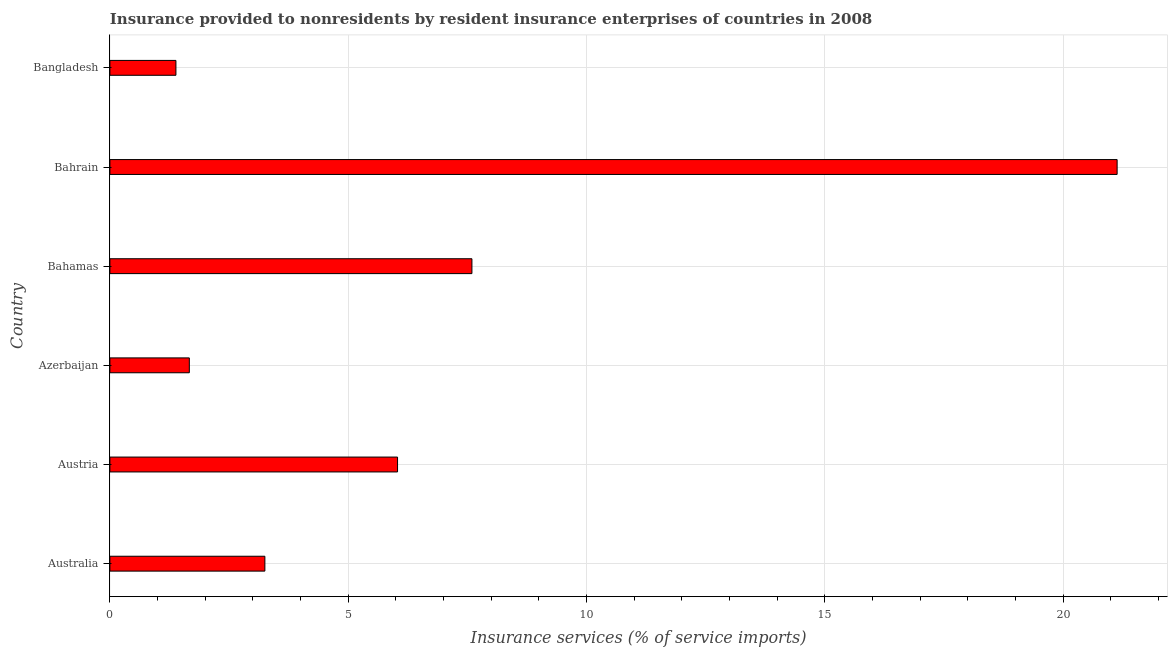Does the graph contain any zero values?
Provide a succinct answer. No. Does the graph contain grids?
Your response must be concise. Yes. What is the title of the graph?
Offer a terse response. Insurance provided to nonresidents by resident insurance enterprises of countries in 2008. What is the label or title of the X-axis?
Provide a short and direct response. Insurance services (% of service imports). What is the insurance and financial services in Australia?
Your answer should be very brief. 3.25. Across all countries, what is the maximum insurance and financial services?
Provide a succinct answer. 21.13. Across all countries, what is the minimum insurance and financial services?
Offer a very short reply. 1.39. In which country was the insurance and financial services maximum?
Give a very brief answer. Bahrain. What is the sum of the insurance and financial services?
Ensure brevity in your answer.  41.07. What is the difference between the insurance and financial services in Austria and Azerbaijan?
Give a very brief answer. 4.37. What is the average insurance and financial services per country?
Your answer should be compact. 6.84. What is the median insurance and financial services?
Your answer should be very brief. 4.64. What is the ratio of the insurance and financial services in Australia to that in Bahrain?
Your answer should be very brief. 0.15. Is the insurance and financial services in Bahamas less than that in Bahrain?
Offer a terse response. Yes. Is the difference between the insurance and financial services in Australia and Bangladesh greater than the difference between any two countries?
Make the answer very short. No. What is the difference between the highest and the second highest insurance and financial services?
Provide a short and direct response. 13.54. What is the difference between the highest and the lowest insurance and financial services?
Offer a very short reply. 19.75. In how many countries, is the insurance and financial services greater than the average insurance and financial services taken over all countries?
Keep it short and to the point. 2. How many countries are there in the graph?
Give a very brief answer. 6. Are the values on the major ticks of X-axis written in scientific E-notation?
Offer a very short reply. No. What is the Insurance services (% of service imports) in Australia?
Give a very brief answer. 3.25. What is the Insurance services (% of service imports) in Austria?
Give a very brief answer. 6.04. What is the Insurance services (% of service imports) of Azerbaijan?
Your response must be concise. 1.67. What is the Insurance services (% of service imports) in Bahamas?
Provide a succinct answer. 7.6. What is the Insurance services (% of service imports) of Bahrain?
Your answer should be compact. 21.13. What is the Insurance services (% of service imports) in Bangladesh?
Keep it short and to the point. 1.39. What is the difference between the Insurance services (% of service imports) in Australia and Austria?
Your response must be concise. -2.78. What is the difference between the Insurance services (% of service imports) in Australia and Azerbaijan?
Provide a succinct answer. 1.59. What is the difference between the Insurance services (% of service imports) in Australia and Bahamas?
Give a very brief answer. -4.34. What is the difference between the Insurance services (% of service imports) in Australia and Bahrain?
Your response must be concise. -17.88. What is the difference between the Insurance services (% of service imports) in Australia and Bangladesh?
Your response must be concise. 1.87. What is the difference between the Insurance services (% of service imports) in Austria and Azerbaijan?
Keep it short and to the point. 4.37. What is the difference between the Insurance services (% of service imports) in Austria and Bahamas?
Make the answer very short. -1.56. What is the difference between the Insurance services (% of service imports) in Austria and Bahrain?
Your answer should be very brief. -15.1. What is the difference between the Insurance services (% of service imports) in Austria and Bangladesh?
Your answer should be compact. 4.65. What is the difference between the Insurance services (% of service imports) in Azerbaijan and Bahamas?
Make the answer very short. -5.93. What is the difference between the Insurance services (% of service imports) in Azerbaijan and Bahrain?
Give a very brief answer. -19.47. What is the difference between the Insurance services (% of service imports) in Azerbaijan and Bangladesh?
Your answer should be compact. 0.28. What is the difference between the Insurance services (% of service imports) in Bahamas and Bahrain?
Offer a very short reply. -13.54. What is the difference between the Insurance services (% of service imports) in Bahamas and Bangladesh?
Your answer should be compact. 6.21. What is the difference between the Insurance services (% of service imports) in Bahrain and Bangladesh?
Keep it short and to the point. 19.75. What is the ratio of the Insurance services (% of service imports) in Australia to that in Austria?
Your response must be concise. 0.54. What is the ratio of the Insurance services (% of service imports) in Australia to that in Azerbaijan?
Your answer should be very brief. 1.95. What is the ratio of the Insurance services (% of service imports) in Australia to that in Bahamas?
Your answer should be very brief. 0.43. What is the ratio of the Insurance services (% of service imports) in Australia to that in Bahrain?
Your answer should be very brief. 0.15. What is the ratio of the Insurance services (% of service imports) in Australia to that in Bangladesh?
Ensure brevity in your answer.  2.35. What is the ratio of the Insurance services (% of service imports) in Austria to that in Azerbaijan?
Your response must be concise. 3.62. What is the ratio of the Insurance services (% of service imports) in Austria to that in Bahamas?
Offer a terse response. 0.8. What is the ratio of the Insurance services (% of service imports) in Austria to that in Bahrain?
Your response must be concise. 0.29. What is the ratio of the Insurance services (% of service imports) in Austria to that in Bangladesh?
Offer a very short reply. 4.36. What is the ratio of the Insurance services (% of service imports) in Azerbaijan to that in Bahamas?
Provide a succinct answer. 0.22. What is the ratio of the Insurance services (% of service imports) in Azerbaijan to that in Bahrain?
Provide a short and direct response. 0.08. What is the ratio of the Insurance services (% of service imports) in Azerbaijan to that in Bangladesh?
Provide a short and direct response. 1.2. What is the ratio of the Insurance services (% of service imports) in Bahamas to that in Bahrain?
Your answer should be very brief. 0.36. What is the ratio of the Insurance services (% of service imports) in Bahamas to that in Bangladesh?
Make the answer very short. 5.48. What is the ratio of the Insurance services (% of service imports) in Bahrain to that in Bangladesh?
Ensure brevity in your answer.  15.25. 